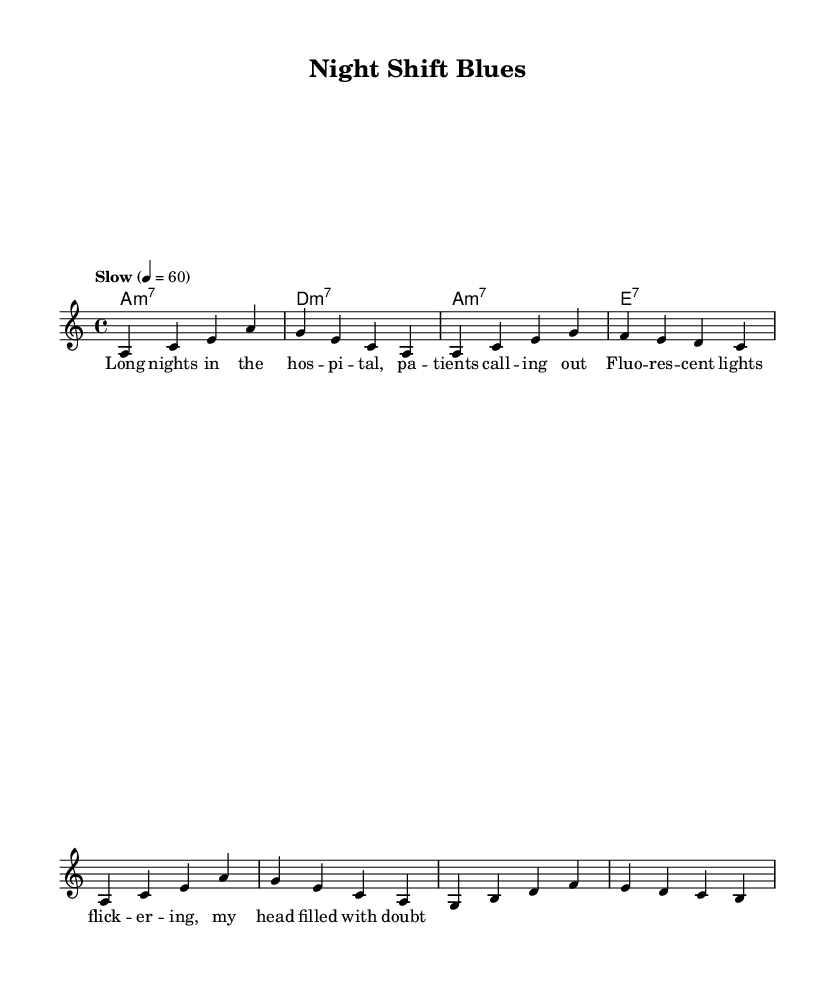What is the key signature of this music? The key signature is identified by observing the notes on the staff for sharps or flats. In this case, there are no sharps or flats indicated, making it A minor, which is the relative minor of C major (which has no accidentals).
Answer: A minor What is the time signature of this music? The time signature is typically notated at the beginning of the piece. Here, it is indicated as 4/4, meaning there are four beats per measure and the quarter note receives one beat.
Answer: 4/4 What is the tempo marking of this music? The tempo is indicated directly under the title or within the score; here it is labeled "Slow" with a metronome marking of 60 beats per minute. This informs the performer to play at a slow pace.
Answer: Slow How many measures are there in this melody? By counting the distinct sets of notes grouped by vertical lines on the staff, we find that there are a total of four measures in this melody section.
Answer: Four What type of chord is the first chord listed? The first chord is labeled as "a1:m7", which identifies an A minor 7 chord. This notation indicates the root note (A) and that it is a minor seventh chord due to the "m7" designation.
Answer: A minor 7 Is there a repeated lyric line in the lyrics? By analyzing the lyrics, the first two lines contain similar phrasing and sentiment about nighttime hospital duties; this convincingly shows a thematic repetition which is common in blues.
Answer: Yes How would you describe the style of this piece? This piece captures the essence of the Blues style, characterized by its use of minor chords, lamenting lyrics about hardship, and the emotional expression of the struggles faced during night shifts.
Answer: Blues 